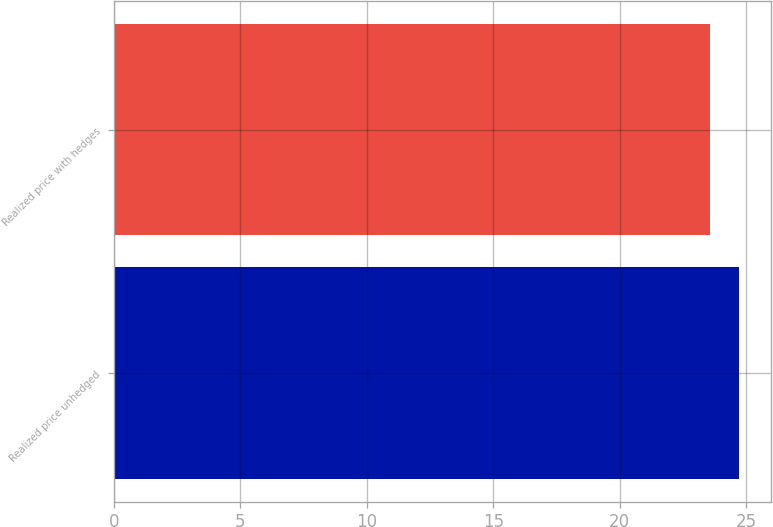Convert chart. <chart><loc_0><loc_0><loc_500><loc_500><bar_chart><fcel>Realized price unhedged<fcel>Realized price with hedges<nl><fcel>24.74<fcel>23.57<nl></chart> 